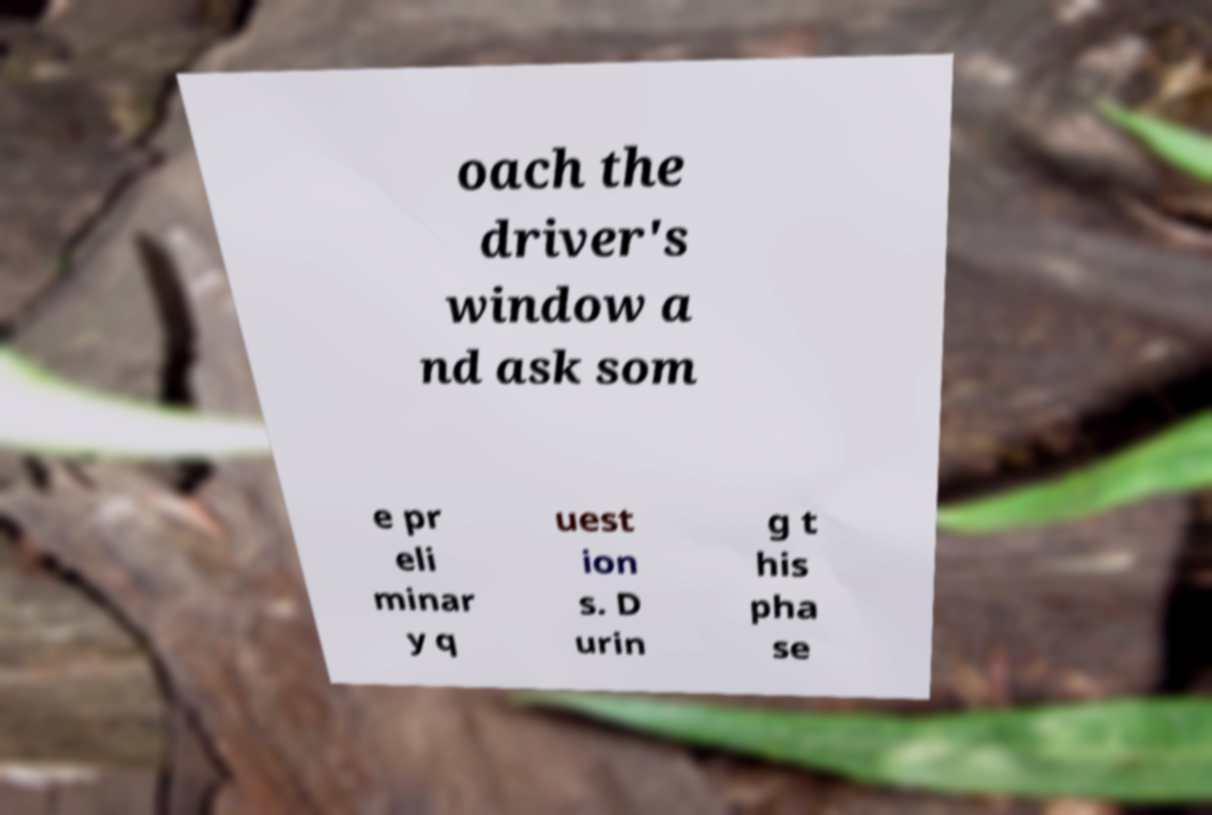Could you assist in decoding the text presented in this image and type it out clearly? oach the driver's window a nd ask som e pr eli minar y q uest ion s. D urin g t his pha se 